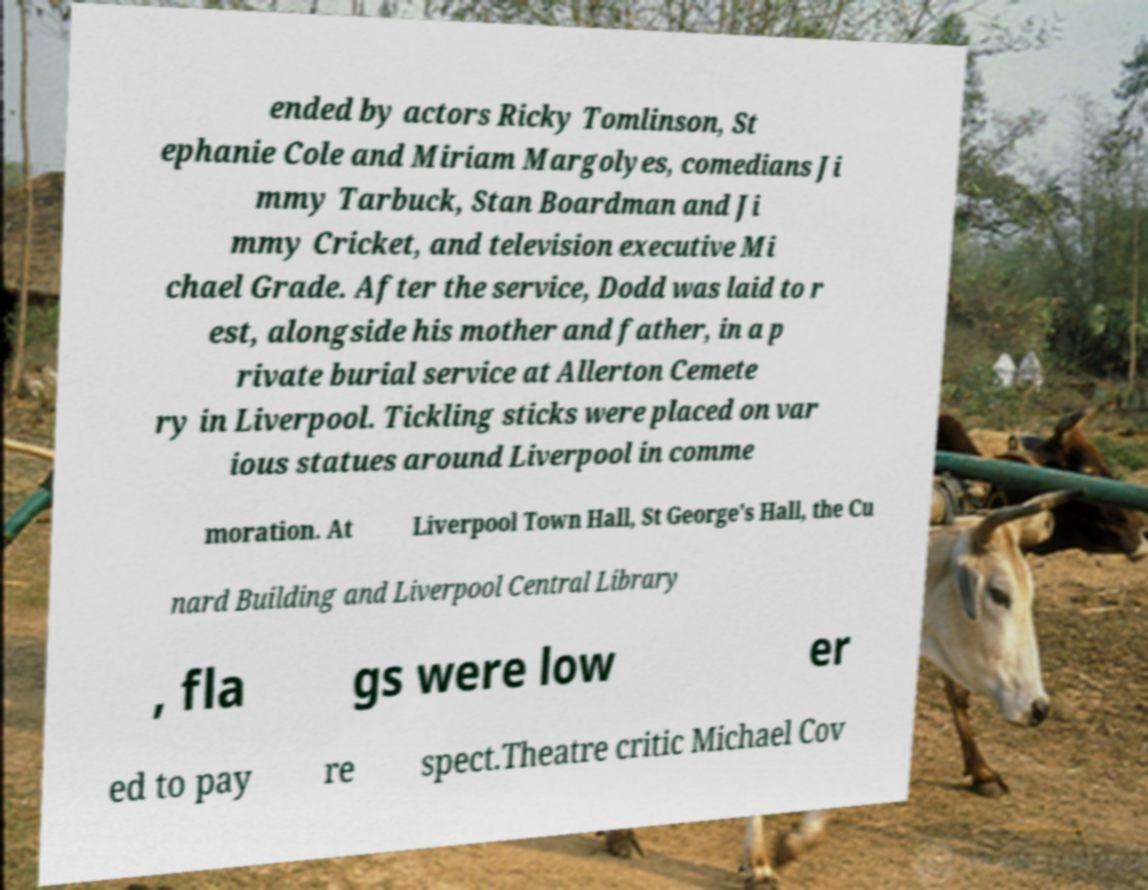Can you read and provide the text displayed in the image?This photo seems to have some interesting text. Can you extract and type it out for me? ended by actors Ricky Tomlinson, St ephanie Cole and Miriam Margolyes, comedians Ji mmy Tarbuck, Stan Boardman and Ji mmy Cricket, and television executive Mi chael Grade. After the service, Dodd was laid to r est, alongside his mother and father, in a p rivate burial service at Allerton Cemete ry in Liverpool. Tickling sticks were placed on var ious statues around Liverpool in comme moration. At Liverpool Town Hall, St George's Hall, the Cu nard Building and Liverpool Central Library , fla gs were low er ed to pay re spect.Theatre critic Michael Cov 